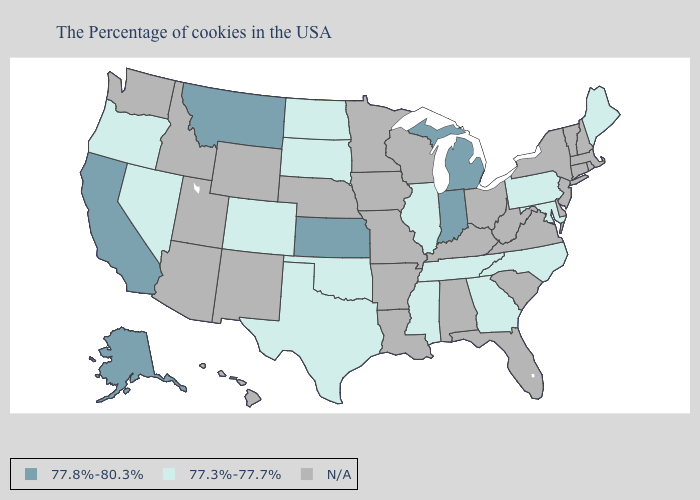Among the states that border Kansas , which have the highest value?
Give a very brief answer. Oklahoma, Colorado. Does South Dakota have the highest value in the MidWest?
Concise answer only. No. Does Michigan have the lowest value in the MidWest?
Answer briefly. No. Among the states that border Alabama , which have the highest value?
Write a very short answer. Georgia, Tennessee, Mississippi. How many symbols are there in the legend?
Write a very short answer. 3. How many symbols are there in the legend?
Quick response, please. 3. Name the states that have a value in the range N/A?
Keep it brief. Massachusetts, Rhode Island, New Hampshire, Vermont, Connecticut, New York, New Jersey, Delaware, Virginia, South Carolina, West Virginia, Ohio, Florida, Kentucky, Alabama, Wisconsin, Louisiana, Missouri, Arkansas, Minnesota, Iowa, Nebraska, Wyoming, New Mexico, Utah, Arizona, Idaho, Washington, Hawaii. What is the value of Florida?
Write a very short answer. N/A. What is the value of Hawaii?
Keep it brief. N/A. What is the highest value in the MidWest ?
Answer briefly. 77.8%-80.3%. What is the lowest value in the Northeast?
Quick response, please. 77.3%-77.7%. What is the value of New York?
Give a very brief answer. N/A. Does Tennessee have the lowest value in the USA?
Answer briefly. Yes. 